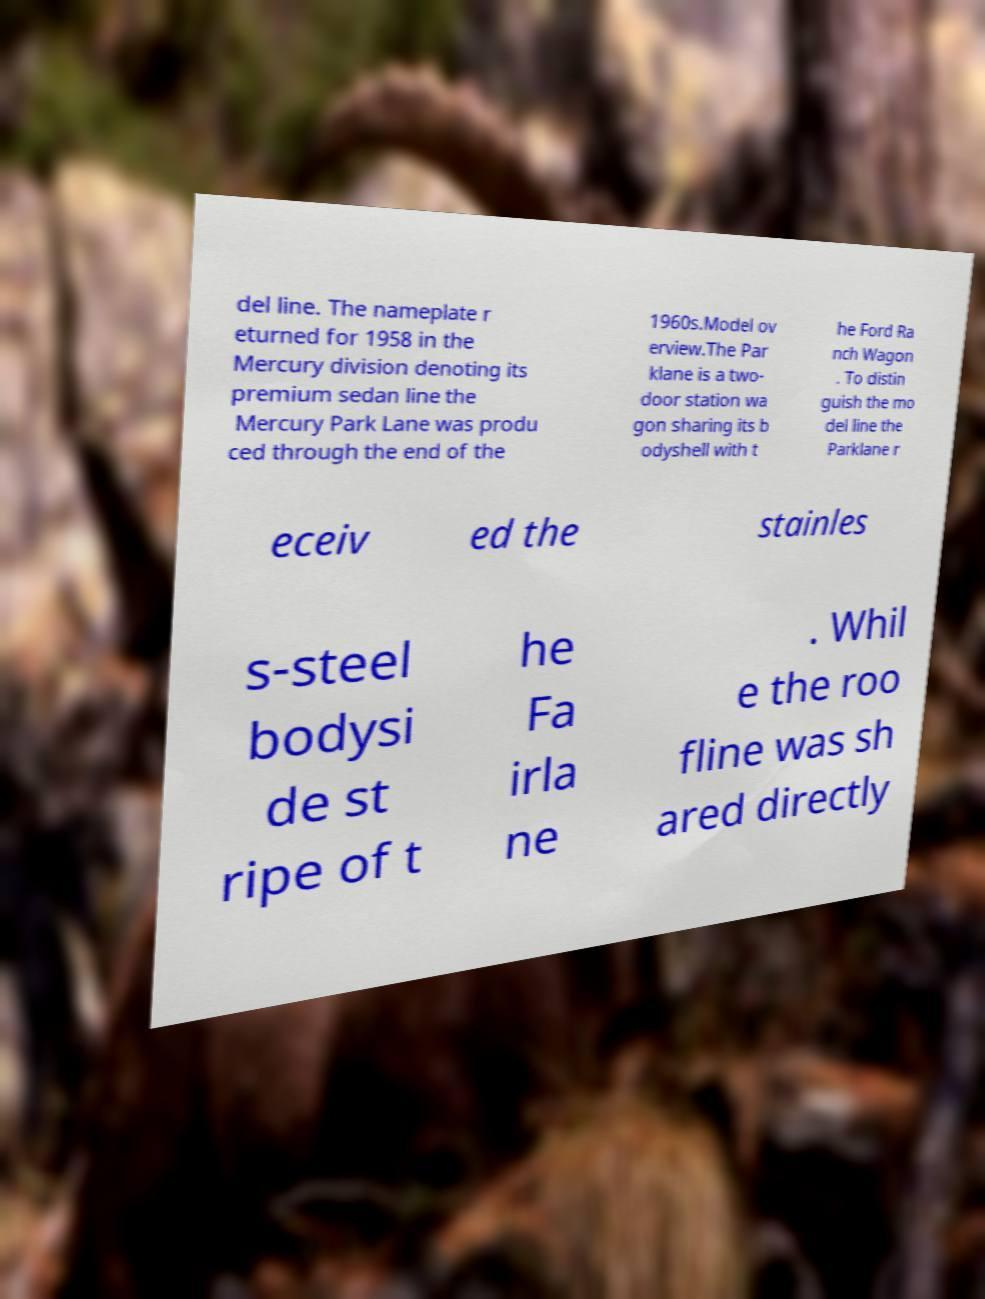Could you assist in decoding the text presented in this image and type it out clearly? del line. The nameplate r eturned for 1958 in the Mercury division denoting its premium sedan line the Mercury Park Lane was produ ced through the end of the 1960s.Model ov erview.The Par klane is a two- door station wa gon sharing its b odyshell with t he Ford Ra nch Wagon . To distin guish the mo del line the Parklane r eceiv ed the stainles s-steel bodysi de st ripe of t he Fa irla ne . Whil e the roo fline was sh ared directly 